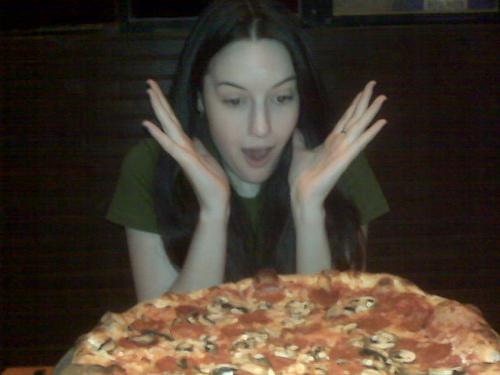Is the woman going to eat the pizza all by herself?
Answer briefly. No. Who has her mouth open?
Short answer required. Girl. Is this person excited?
Concise answer only. Yes. 